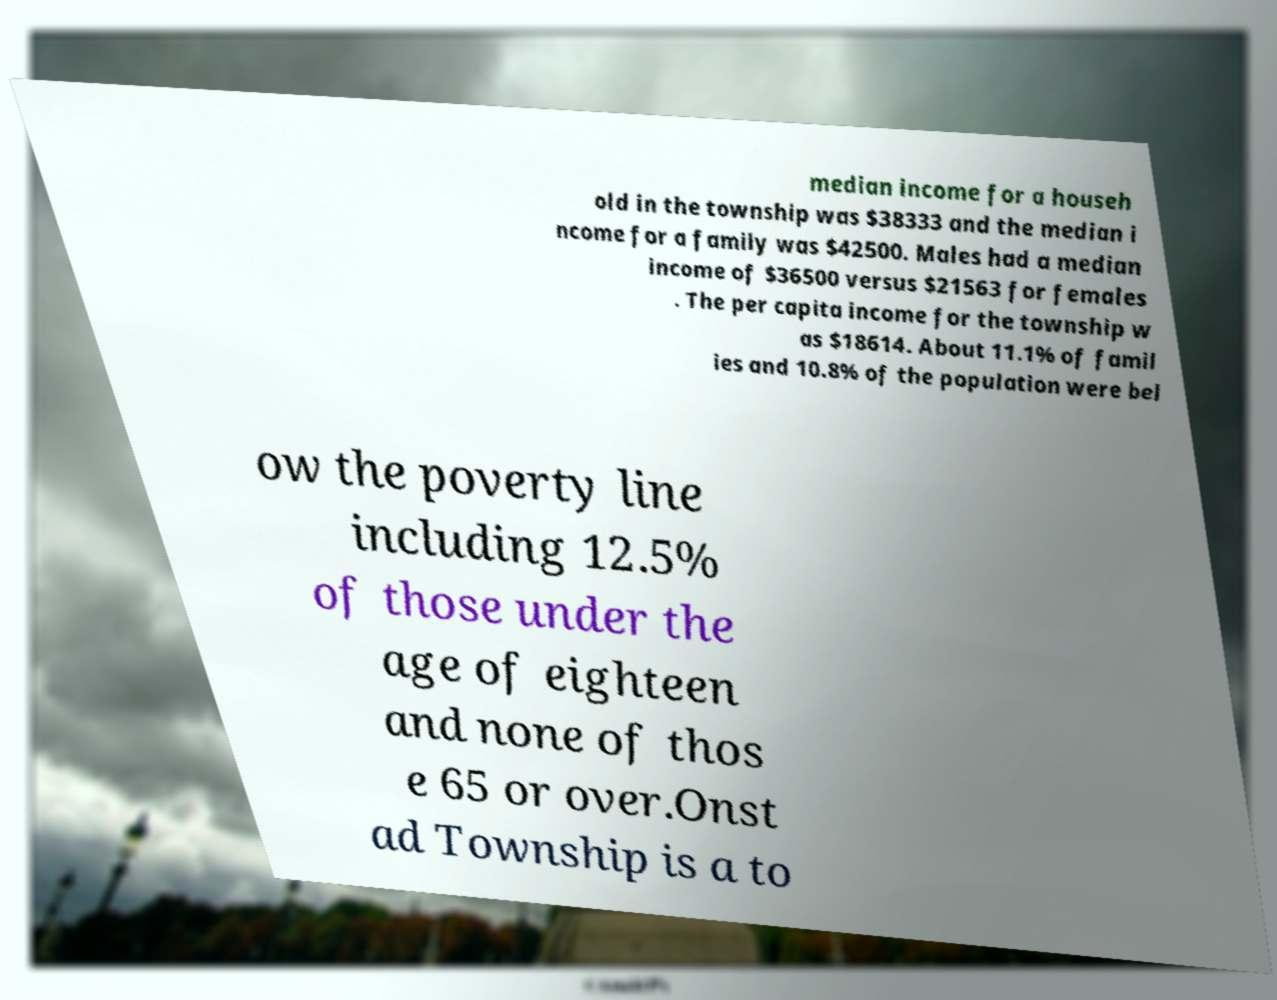Can you accurately transcribe the text from the provided image for me? median income for a househ old in the township was $38333 and the median i ncome for a family was $42500. Males had a median income of $36500 versus $21563 for females . The per capita income for the township w as $18614. About 11.1% of famil ies and 10.8% of the population were bel ow the poverty line including 12.5% of those under the age of eighteen and none of thos e 65 or over.Onst ad Township is a to 